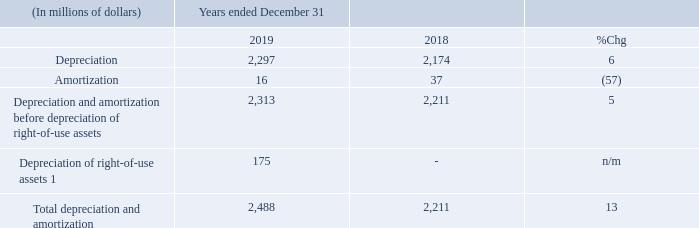DEPRECIATION AND AMORTIZATION
1 See “Accounting Policies” for more information.
1 See “Accounting Policies” for more information. Total depreciation and amortization increased this year primarily as a result of depreciation of right-of-use assets due to our adoption of IFRS 16 on January 1, 2019 and higher capital expenditures over the past several years. See “Capital Expenditures” for more information.
What caused the increase in the total depreciation and amortization? Result of depreciation of right-of-use assets due to our adoption of ifrs 16 on january 1, 2019 and higher capital expenditures over the past several years. What was the depreciation in 2019?
Answer scale should be: million. 2,297. What was the Depreciation of right-of-use assets in 2019?
Answer scale should be: million. 175. What was the increase / (decrease) in the Depreciation from 2018 to 2019?
Answer scale should be: million. 2,297 - 2,174
Answer: 123. What was the average amortization?
Answer scale should be: million. (16 + 37) / 2
Answer: 26.5. What was the increase / (decrease) in the Total depreciation and amortization from 2018 to 2019?
Answer scale should be: million. 2,488 - 2,211
Answer: 277. 